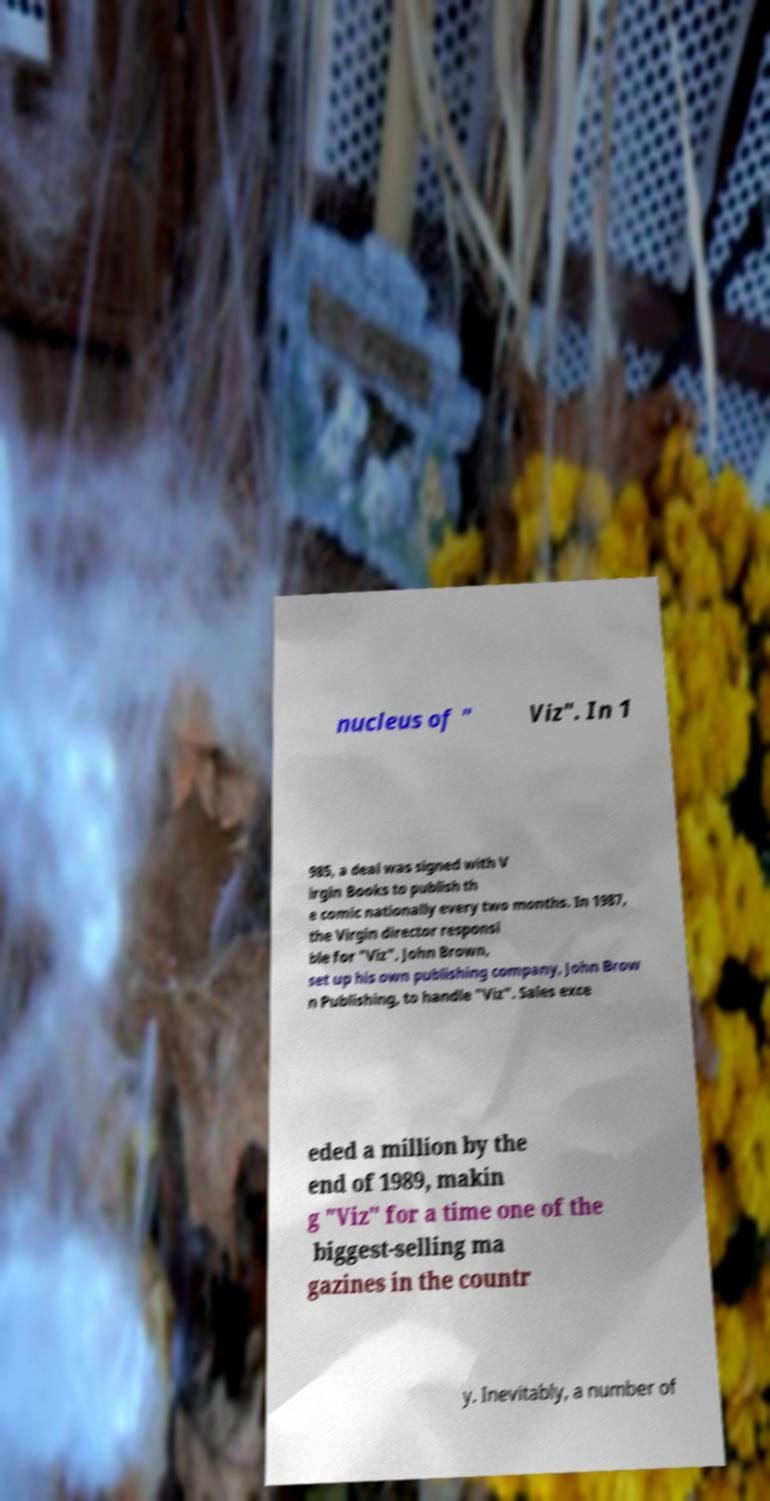Could you extract and type out the text from this image? nucleus of " Viz". In 1 985, a deal was signed with V irgin Books to publish th e comic nationally every two months. In 1987, the Virgin director responsi ble for "Viz", John Brown, set up his own publishing company, John Brow n Publishing, to handle "Viz". Sales exce eded a million by the end of 1989, makin g "Viz" for a time one of the biggest-selling ma gazines in the countr y. Inevitably, a number of 